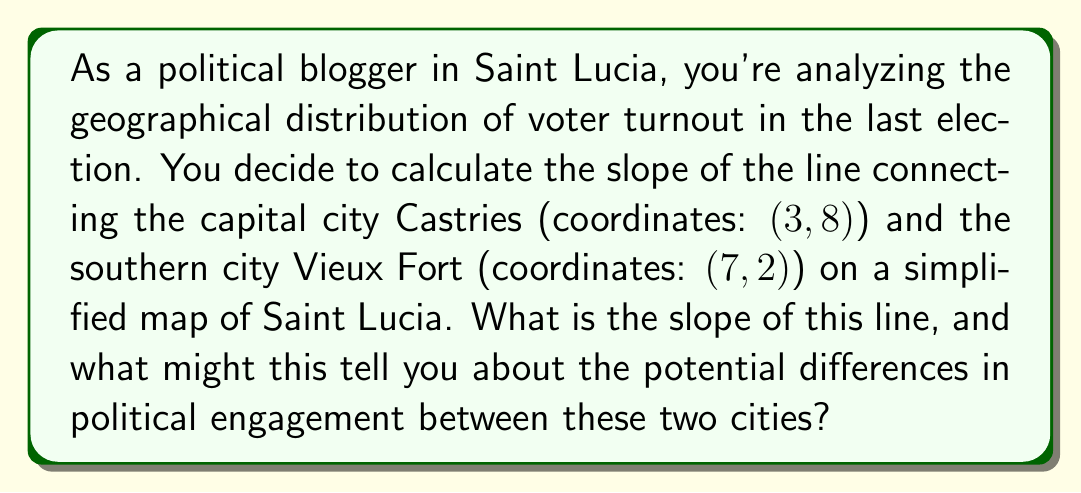Teach me how to tackle this problem. To calculate the slope of the line connecting Castries and Vieux Fort, we'll use the slope formula:

$$ m = \frac{y_2 - y_1}{x_2 - x_1} $$

Where:
$(x_1, y_1)$ represents the coordinates of Castries (3, 8)
$(x_2, y_2)$ represents the coordinates of Vieux Fort (7, 2)

Let's substitute these values into the formula:

$$ m = \frac{2 - 8}{7 - 3} = \frac{-6}{4} = -\frac{3}{2} = -1.5 $$

The slope is negative, indicating that as we move from Castries to Vieux Fort, the line descends on the map. This could potentially represent:

1. A decrease in population density from north to south
2. A change in elevation (Castries being higher than Vieux Fort)
3. Possibly, a trend in voter turnout or political engagement decreasing from north to south

The magnitude of the slope (1.5) suggests a relatively steep decline, which could indicate significant differences between the two cities in terms of demographics, economic factors, or political leanings that might influence voter behavior.

[asy]
import geometry;

size(200);
dot((3,8),red);
dot((7,2),red);
draw((3,8)--(7,2),blue);
label("Castries (3,8)", (3,8), NE);
label("Vieux Fort (7,2)", (7,2), SE);
xaxis(0,8,Arrow);
yaxis(0,9,Arrow);
[/asy]
Answer: The slope of the line connecting Castries and Vieux Fort is $-\frac{3}{2}$ or $-1.5$. 